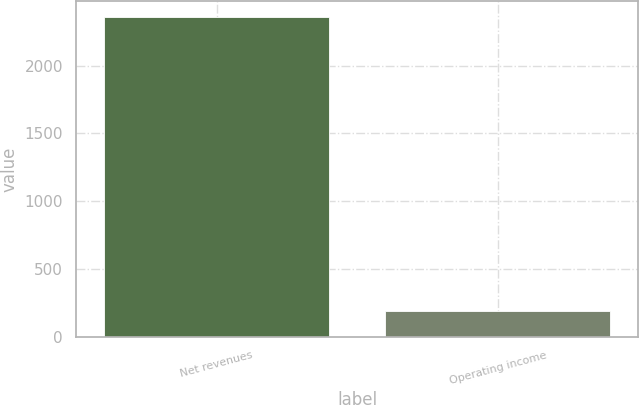Convert chart. <chart><loc_0><loc_0><loc_500><loc_500><bar_chart><fcel>Net revenues<fcel>Operating income<nl><fcel>2355<fcel>187<nl></chart> 